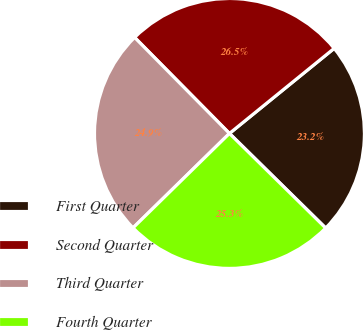Convert chart to OTSL. <chart><loc_0><loc_0><loc_500><loc_500><pie_chart><fcel>First Quarter<fcel>Second Quarter<fcel>Third Quarter<fcel>Fourth Quarter<nl><fcel>23.22%<fcel>26.54%<fcel>24.93%<fcel>25.3%<nl></chart> 